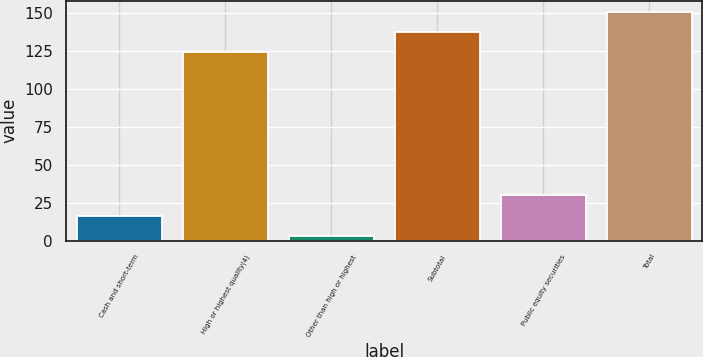Convert chart to OTSL. <chart><loc_0><loc_0><loc_500><loc_500><bar_chart><fcel>Cash and short-term<fcel>High or highest quality(4)<fcel>Other than high or highest<fcel>Subtotal<fcel>Public equity securities<fcel>Total<nl><fcel>16.49<fcel>123.8<fcel>3.3<fcel>136.99<fcel>29.68<fcel>150.18<nl></chart> 